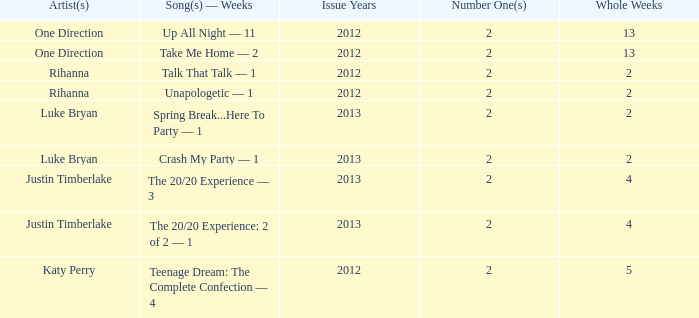What is the longest number of weeks any 1 song was at number #1? 13.0. 